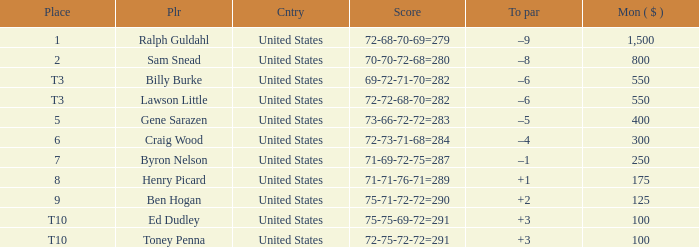Which country has a prize smaller than $250 and the player Henry Picard? United States. Give me the full table as a dictionary. {'header': ['Place', 'Plr', 'Cntry', 'Score', 'To par', 'Mon ( $ )'], 'rows': [['1', 'Ralph Guldahl', 'United States', '72-68-70-69=279', '–9', '1,500'], ['2', 'Sam Snead', 'United States', '70-70-72-68=280', '–8', '800'], ['T3', 'Billy Burke', 'United States', '69-72-71-70=282', '–6', '550'], ['T3', 'Lawson Little', 'United States', '72-72-68-70=282', '–6', '550'], ['5', 'Gene Sarazen', 'United States', '73-66-72-72=283', '–5', '400'], ['6', 'Craig Wood', 'United States', '72-73-71-68=284', '–4', '300'], ['7', 'Byron Nelson', 'United States', '71-69-72-75=287', '–1', '250'], ['8', 'Henry Picard', 'United States', '71-71-76-71=289', '+1', '175'], ['9', 'Ben Hogan', 'United States', '75-71-72-72=290', '+2', '125'], ['T10', 'Ed Dudley', 'United States', '75-75-69-72=291', '+3', '100'], ['T10', 'Toney Penna', 'United States', '72-75-72-72=291', '+3', '100']]} 